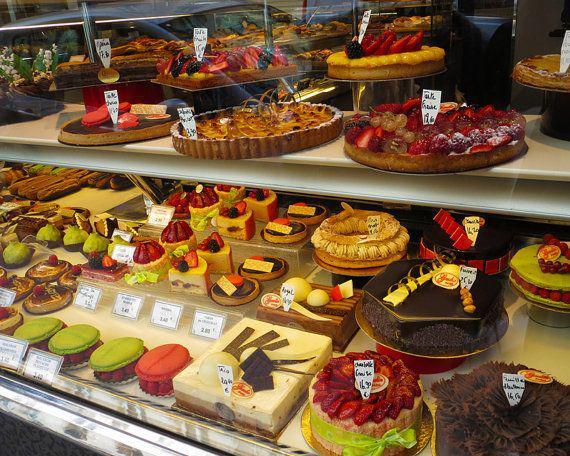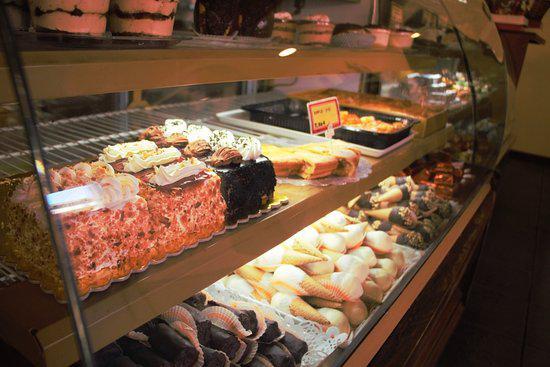The first image is the image on the left, the second image is the image on the right. Considering the images on both sides, is "In the image to the right, at least one cake has strawberry on it." valid? Answer yes or no. No. The first image is the image on the left, the second image is the image on the right. Evaluate the accuracy of this statement regarding the images: "An image features cakes on pedestal stands under a top tier supported by ornate columns with more cakes on pedestals.". Is it true? Answer yes or no. No. 